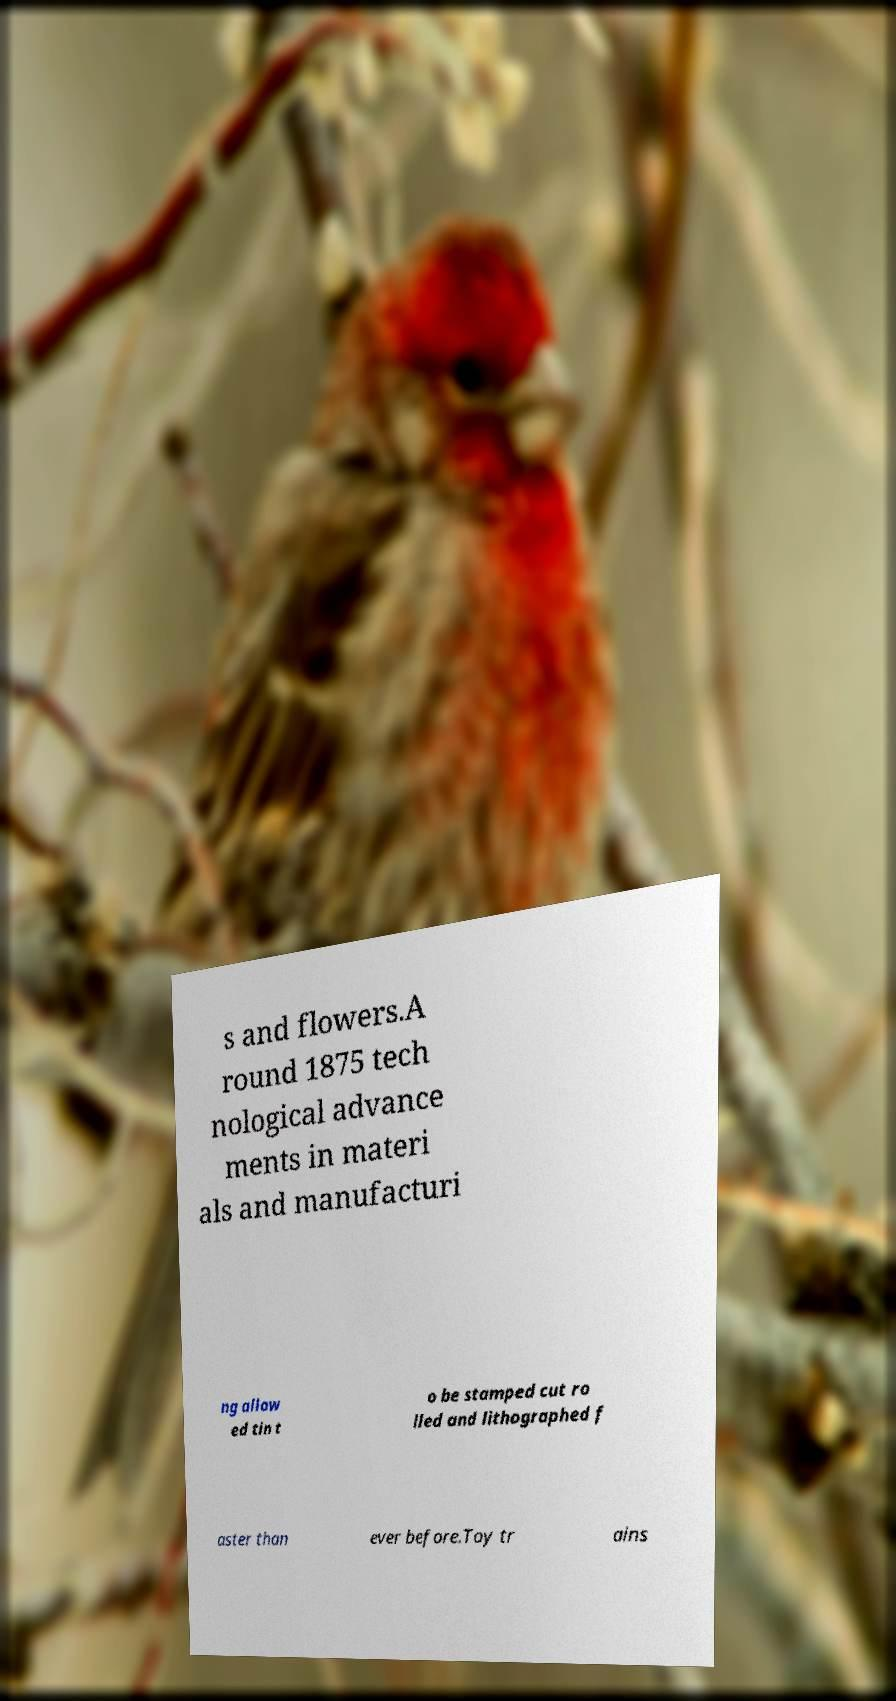Please identify and transcribe the text found in this image. s and flowers.A round 1875 tech nological advance ments in materi als and manufacturi ng allow ed tin t o be stamped cut ro lled and lithographed f aster than ever before.Toy tr ains 